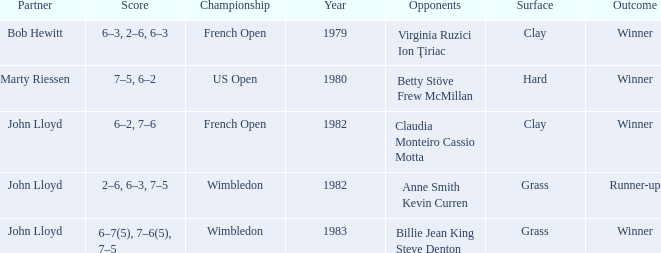What was the surface for events held in 1983? Grass. 